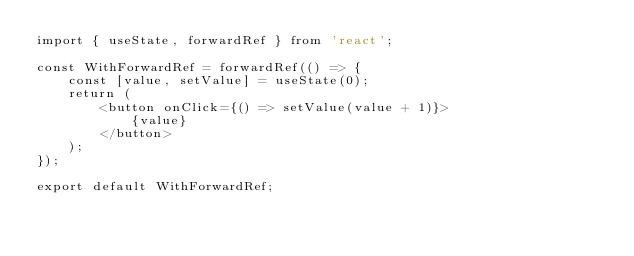<code> <loc_0><loc_0><loc_500><loc_500><_TypeScript_>import { useState, forwardRef } from 'react';

const WithForwardRef = forwardRef(() => {
    const [value, setValue] = useState(0);
    return (
        <button onClick={() => setValue(value + 1)}>
            {value}
        </button>
    );
});

export default WithForwardRef;
</code> 